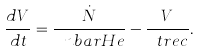<formula> <loc_0><loc_0><loc_500><loc_500>\frac { d V } { d t } = \frac { \dot { N } } { \ n b a r { H e } } - \frac { V } { \ t r e c } .</formula> 